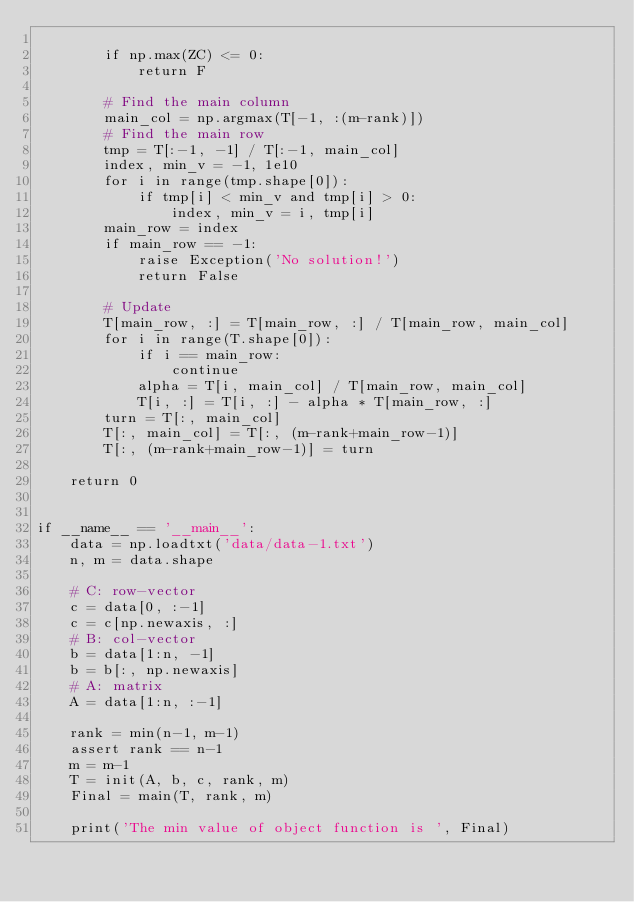<code> <loc_0><loc_0><loc_500><loc_500><_Python_>
        if np.max(ZC) <= 0:
            return F

        # Find the main column
        main_col = np.argmax(T[-1, :(m-rank)])
        # Find the main row
        tmp = T[:-1, -1] / T[:-1, main_col]
        index, min_v = -1, 1e10
        for i in range(tmp.shape[0]):
            if tmp[i] < min_v and tmp[i] > 0:
                index, min_v = i, tmp[i]
        main_row = index
        if main_row == -1:
            raise Exception('No solution!')
            return False

        # Update
        T[main_row, :] = T[main_row, :] / T[main_row, main_col]
        for i in range(T.shape[0]):
            if i == main_row:
                continue
            alpha = T[i, main_col] / T[main_row, main_col]
            T[i, :] = T[i, :] - alpha * T[main_row, :]
        turn = T[:, main_col]
        T[:, main_col] = T[:, (m-rank+main_row-1)]
        T[:, (m-rank+main_row-1)] = turn

    return 0


if __name__ == '__main__':
    data = np.loadtxt('data/data-1.txt')
    n, m = data.shape

    # C: row-vector
    c = data[0, :-1]
    c = c[np.newaxis, :]
    # B: col-vector
    b = data[1:n, -1]
    b = b[:, np.newaxis]
    # A: matrix
    A = data[1:n, :-1]

    rank = min(n-1, m-1)
    assert rank == n-1
    m = m-1
    T = init(A, b, c, rank, m)
    Final = main(T, rank, m)

    print('The min value of object function is ', Final)</code> 